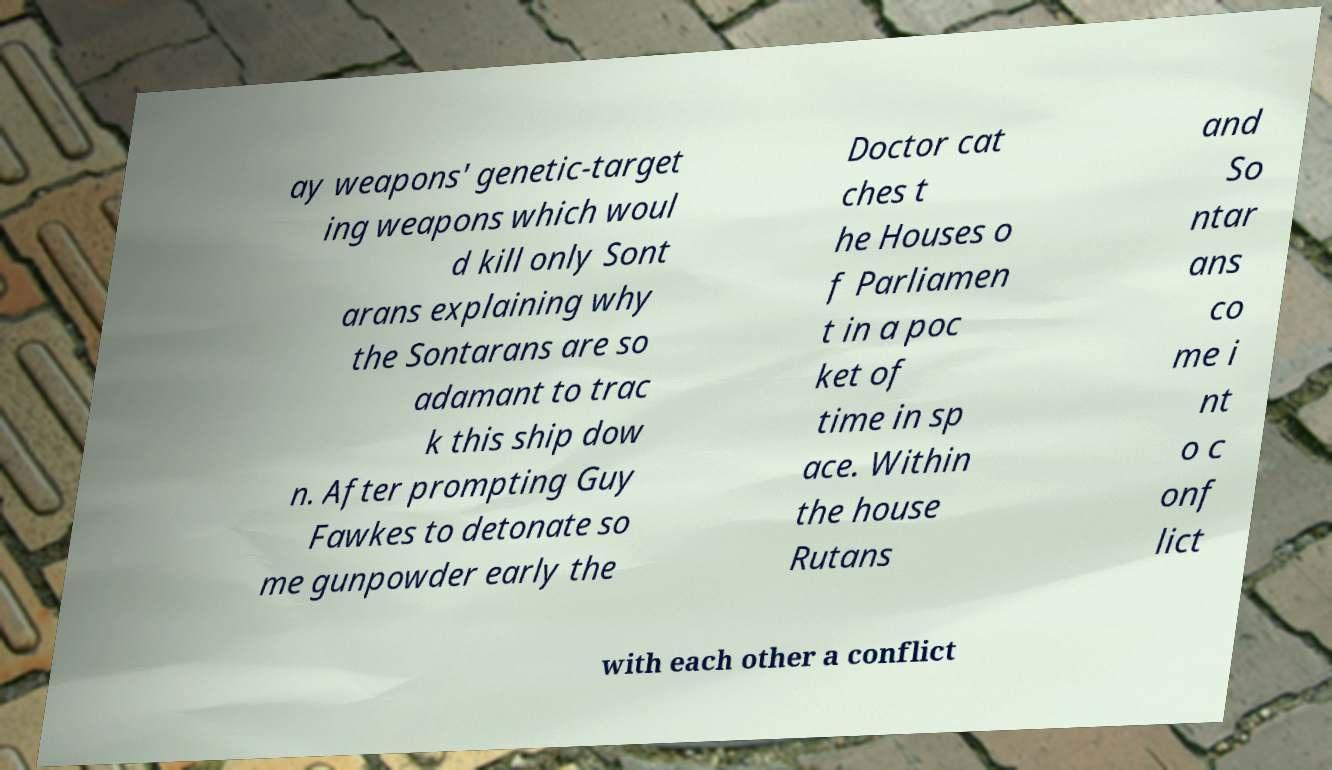Could you extract and type out the text from this image? ay weapons' genetic-target ing weapons which woul d kill only Sont arans explaining why the Sontarans are so adamant to trac k this ship dow n. After prompting Guy Fawkes to detonate so me gunpowder early the Doctor cat ches t he Houses o f Parliamen t in a poc ket of time in sp ace. Within the house Rutans and So ntar ans co me i nt o c onf lict with each other a conflict 